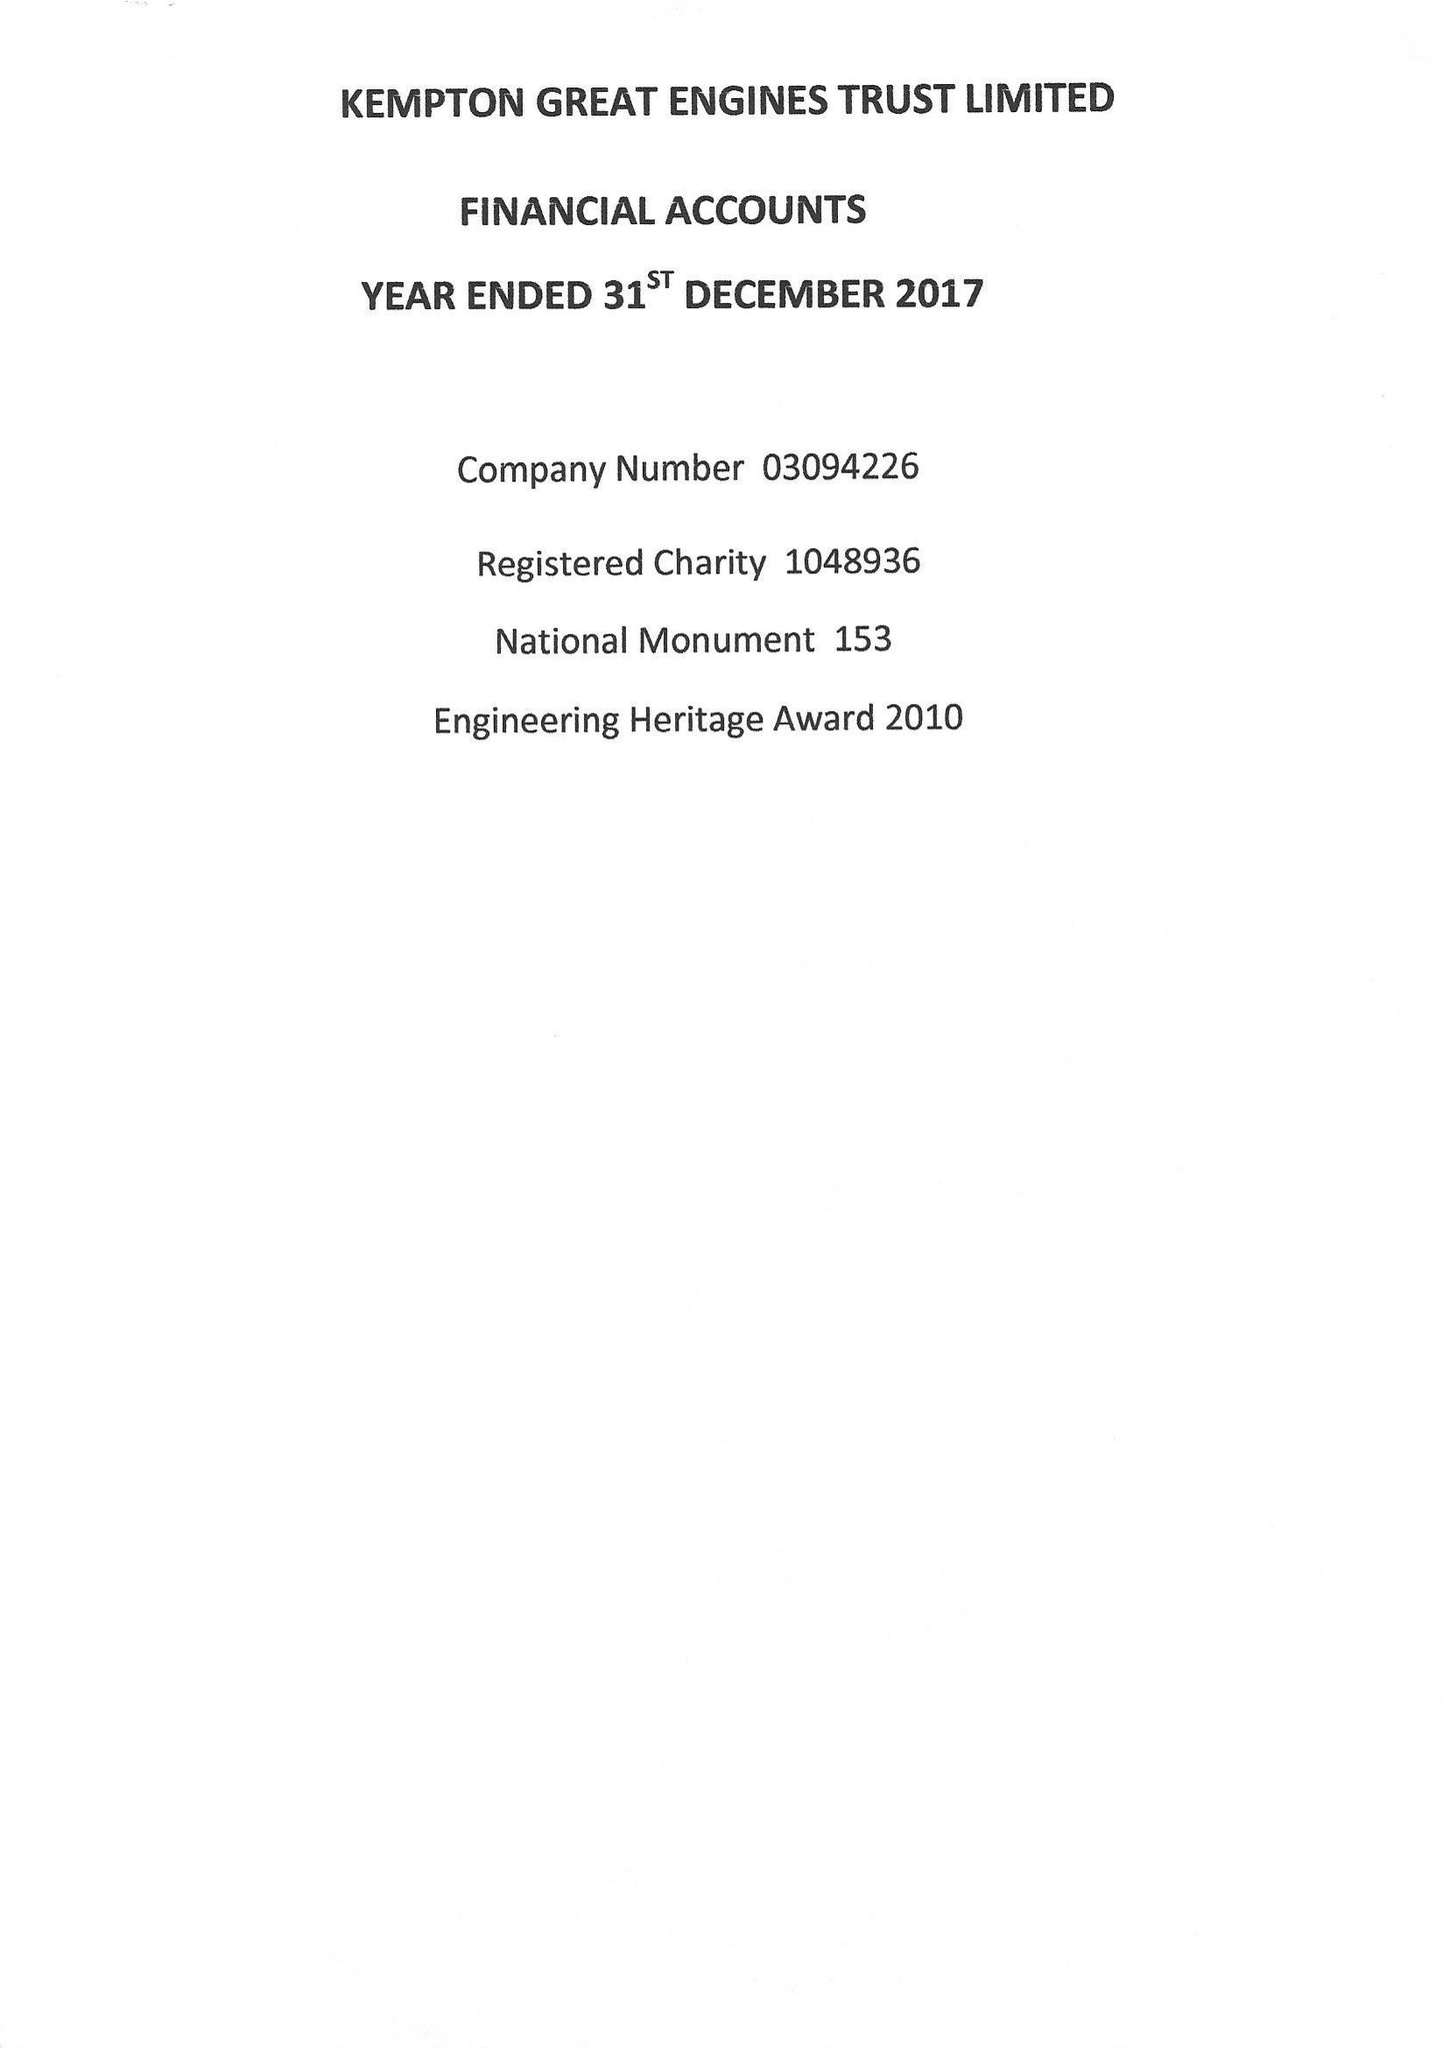What is the value for the charity_name?
Answer the question using a single word or phrase. Kempton Great Engines Trust Ltd. 